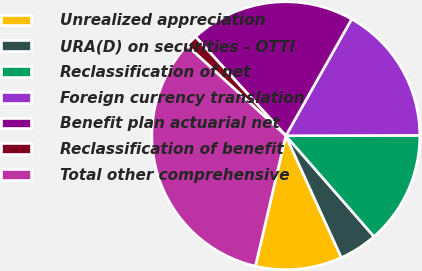Convert chart to OTSL. <chart><loc_0><loc_0><loc_500><loc_500><pie_chart><fcel>Unrealized appreciation<fcel>URA(D) on securities - OTTI<fcel>Reclassification of net<fcel>Foreign currency translation<fcel>Benefit plan actuarial net<fcel>Reclassification of benefit<fcel>Total other comprehensive<nl><fcel>10.45%<fcel>4.63%<fcel>13.61%<fcel>16.78%<fcel>19.95%<fcel>1.46%<fcel>33.12%<nl></chart> 